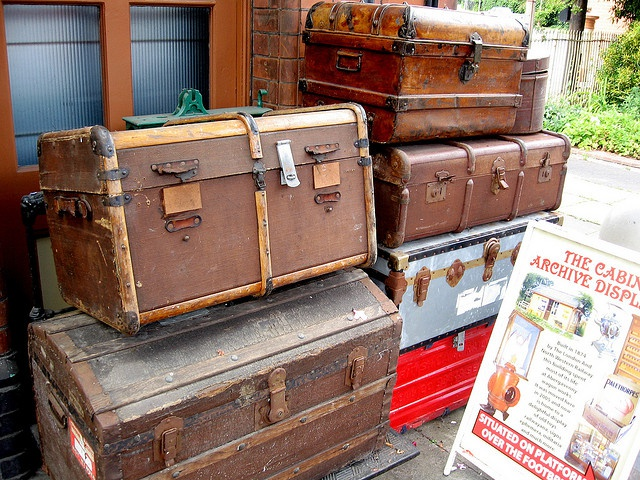Describe the objects in this image and their specific colors. I can see suitcase in maroon, gray, and darkgray tones, suitcase in maroon, gray, tan, and black tones, suitcase in maroon, brown, and black tones, suitcase in maroon, brown, black, and lightgray tones, and suitcase in maroon, lightgray, darkgray, and lightblue tones in this image. 